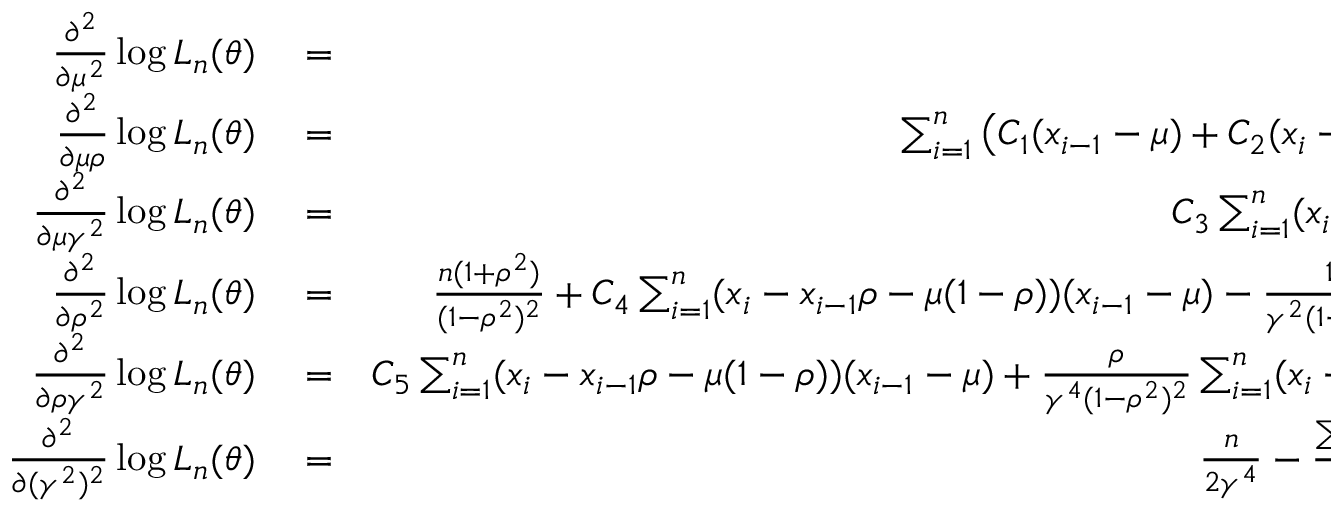Convert formula to latex. <formula><loc_0><loc_0><loc_500><loc_500>\begin{array} { r l r } { \frac { \partial ^ { 2 } } { \partial \mu ^ { 2 } } \log L _ { n } ( \theta ) } & = } & { - \frac { n ( 1 - \rho ) } { \gamma ^ { 2 } ( 1 + \rho ) } , } \\ { \frac { \partial ^ { 2 } } { \partial \mu \rho } \log L _ { n } ( \theta ) } & = } & { \sum _ { i = 1 } ^ { n } \left ( C _ { 1 } ( x _ { i - 1 } - \mu ) + C _ { 2 } ( x _ { i } - x _ { i - 1 } \rho - \mu ( 1 - \rho ) ) \right ) , } \\ { \frac { \partial ^ { 2 } } { \partial \mu \gamma ^ { 2 } } \log L _ { n } ( \theta ) } & = } & { C _ { 3 } \sum _ { i = 1 } ^ { n } ( x _ { i } - x _ { i - 1 } \rho - \mu ( 1 - \rho ) ) , } \\ { \frac { \partial ^ { 2 } } { \partial \rho ^ { 2 } } \log L _ { n } ( \theta ) } & = } & { \frac { n ( 1 + \rho ^ { 2 } ) } { ( 1 - \rho ^ { 2 } ) ^ { 2 } } + C _ { 4 } \sum _ { i = 1 } ^ { n } ( x _ { i } - x _ { i - 1 } \rho - \mu ( 1 - \rho ) ) ( x _ { i - 1 } - \mu ) - \frac { 1 } { \gamma ^ { 2 } ( 1 - \rho ^ { 2 } ) } \sum _ { i = 1 } ^ { n } ( x _ { i - 1 } - \mu ) ^ { 2 } } \\ { \frac { \partial ^ { 2 } } { \partial \rho \gamma ^ { 2 } } \log L _ { n } ( \theta ) } & = } & { C _ { 5 } \sum _ { i = 1 } ^ { n } ( x _ { i } - x _ { i - 1 } \rho - \mu ( 1 - \rho ) ) ( x _ { i - 1 } - \mu ) + \frac { \rho } { \gamma ^ { 4 } ( 1 - \rho ^ { 2 } ) ^ { 2 } } \sum _ { i = 1 } ^ { n } ( x _ { i } - x _ { i - 1 } \rho - \mu ( 1 - \rho ) ) ^ { 2 } , } \\ { \frac { \partial ^ { 2 } } { \partial ( \gamma ^ { 2 } ) ^ { 2 } } \log L _ { n } ( \theta ) } & = } & { \frac { n } { 2 \gamma ^ { 4 } } - \frac { \sum _ { i = 1 } ^ { n } ( x _ { i } - x _ { i - 1 } \rho - \mu ( 1 - \rho ) ) ^ { 2 } } { \gamma ^ { 6 } ( 1 - \rho ^ { 2 } ) } , } \end{array}</formula> 